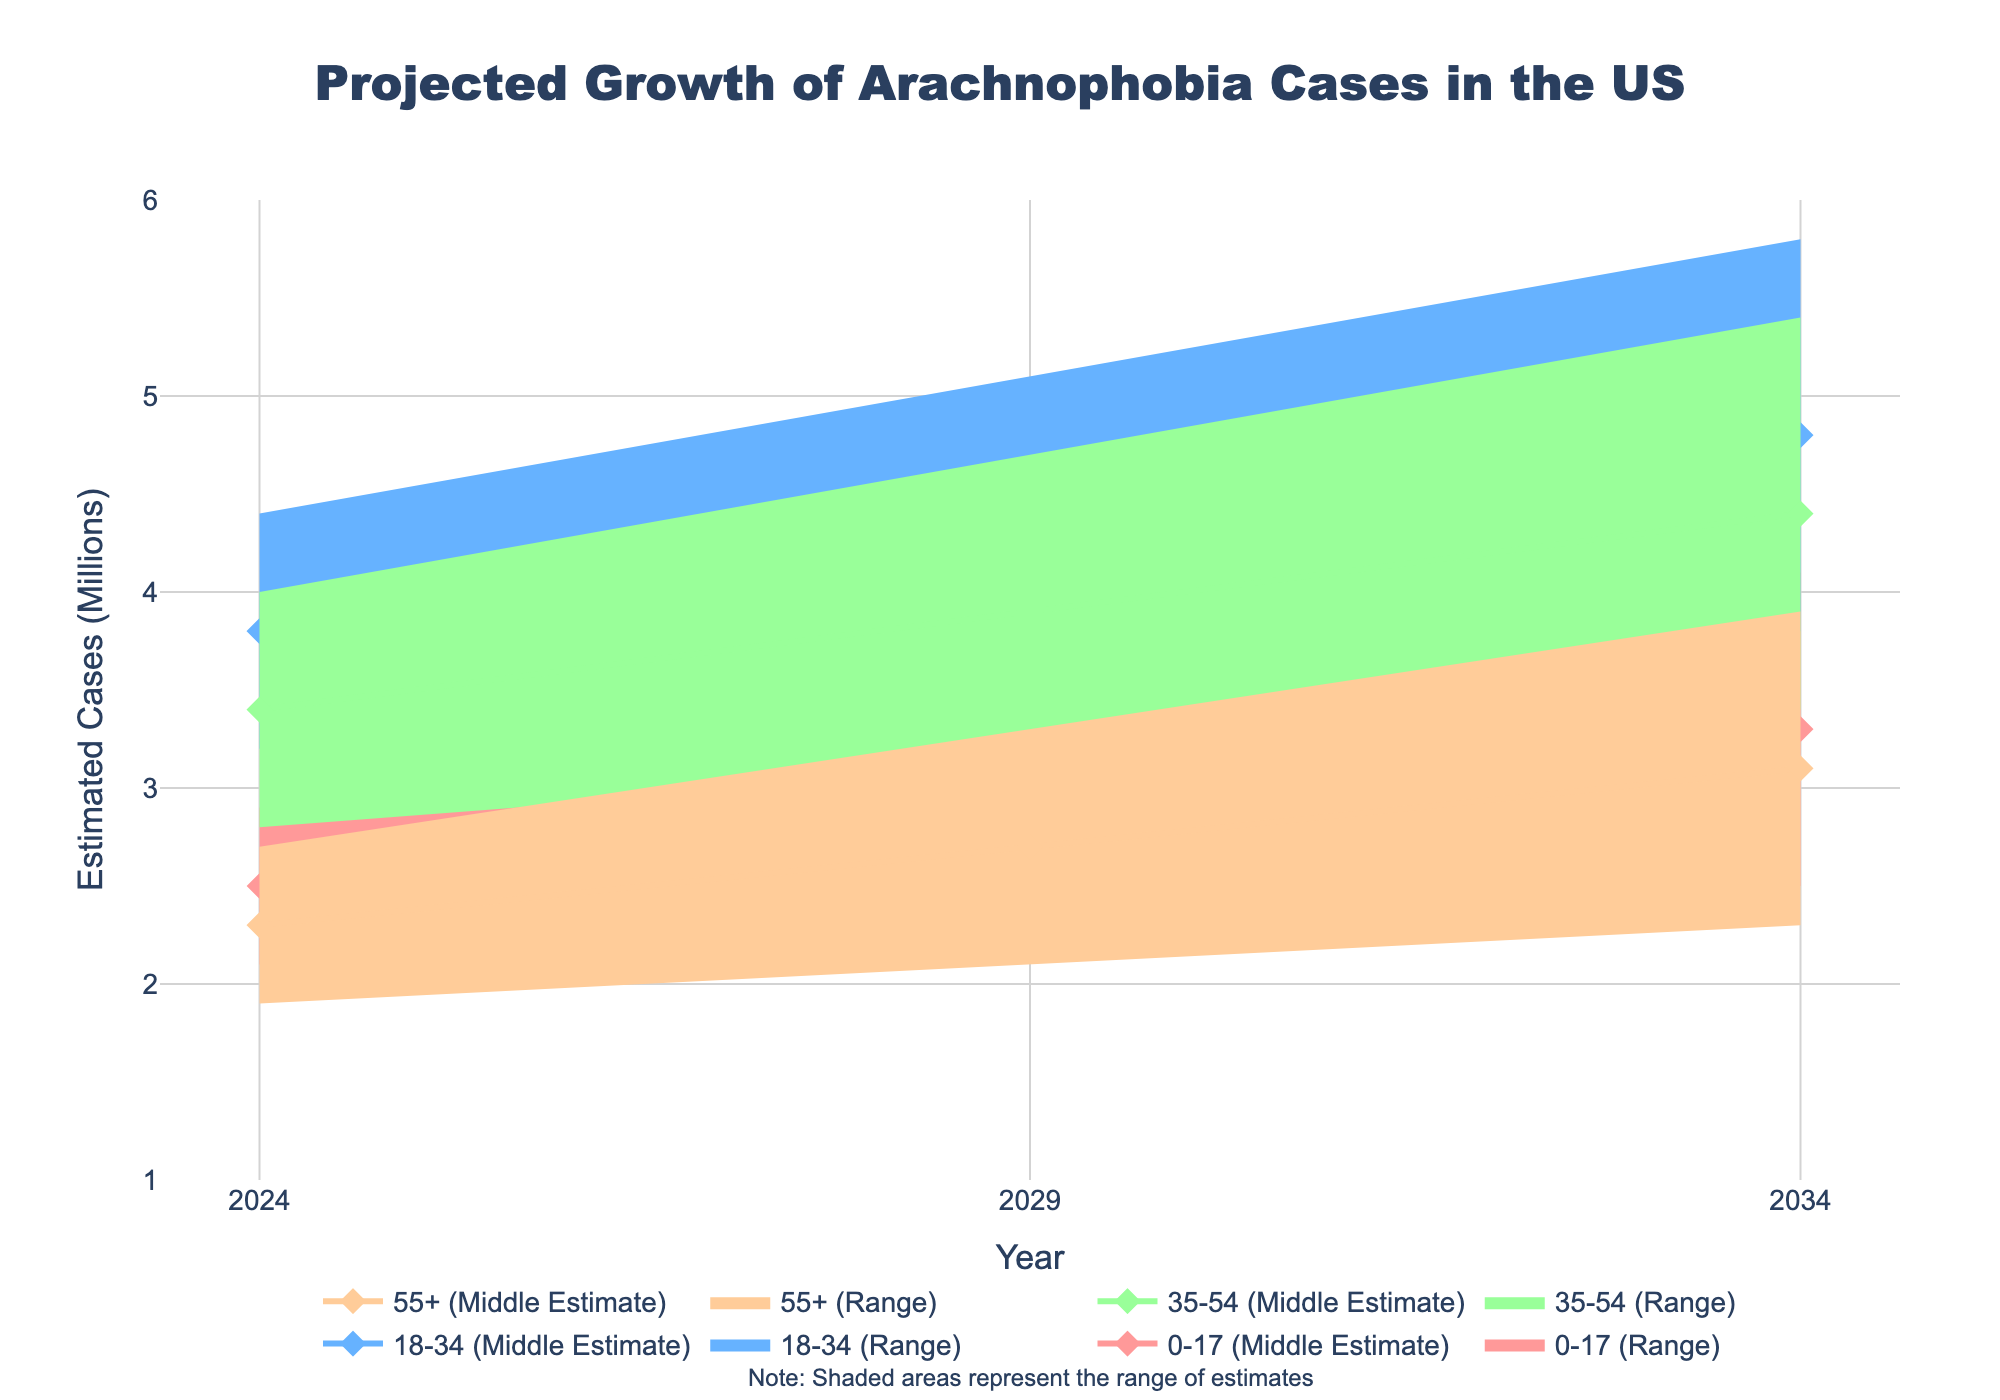What is the title of the plot? The title of the plot is displayed at the top of the chart and provides a quick overview of what the figure is about.
Answer: Projected Growth of Arachnophobia Cases in the US What data is shown on the x-axis? The x-axis indicates the year for which the projections are made. This can be seen from the labels and ticks along the horizontal axis.
Answer: Year What is the range of the y-axis values? By examining the y-axis, we can see the range of estimated cases in millions, from the lowest to highest value indicated.
Answer: 1 to 6 Which age group has the highest middle estimate in 2024? Looking at the 2024 data points, we can compare the middle estimates for each age group to determine the highest value. The middle estimates are marked by points on the lines for each age group.
Answer: 18-34 How do the middle estimates for the age group 0-17 change from 2024 to 2034? We track the middle estimate values for the age group 0-17 across the years listed, and observe the trend. Compare the middle estimate values from 2024 to 2034.
Answer: Increase from 2.5 to 3.3 In which year is the lower middle estimate for the age group 55+ around 2.7 million? We locate the lower middle estimate values for the age group 55+ across the years. The year when the lower middle estimate is approximately 2.7 million is the answer.
Answer: 2029 Which age group shows the highest projected increase in high estimates from 2024 to 2034? Comparing all the high estimates in 2024 with those in 2034, we calculate the differences for each age group and identify the one with the largest increase.
Answer: 18-34 What is the difference between the high estimate and the low estimate for the age group 35-54 in 2029? By finding the high estimate and low estimate values for the age group 35-54 in 2029, we subtract the low estimate from the high estimate to get the difference.
Answer: 1.6 How many different estimate ranges are shaded for the age group 18-34? For the age group 18-34, we observe the different shaded regions in the plot which represent different estimated ranges. Count each distinct shaded range.
Answer: 4 